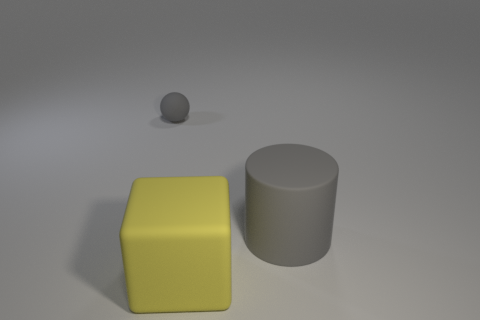Describe the surface the objects are on. The objects are resting on a smooth, flat surface that has a matte texture, suggesting it could be some type of synthetic material or a digitally rendered surface. 